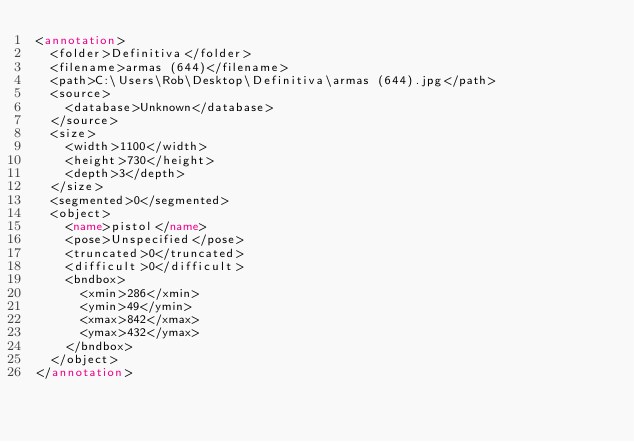Convert code to text. <code><loc_0><loc_0><loc_500><loc_500><_XML_><annotation>
  <folder>Definitiva</folder>
  <filename>armas (644)</filename>
  <path>C:\Users\Rob\Desktop\Definitiva\armas (644).jpg</path>
  <source>
    <database>Unknown</database>
  </source>
  <size>
    <width>1100</width>
    <height>730</height>
    <depth>3</depth>
  </size>
  <segmented>0</segmented>
  <object>
    <name>pistol</name>
    <pose>Unspecified</pose>
    <truncated>0</truncated>
    <difficult>0</difficult>
    <bndbox>
      <xmin>286</xmin>
      <ymin>49</ymin>
      <xmax>842</xmax>
      <ymax>432</ymax>
    </bndbox>
  </object>
</annotation>
</code> 